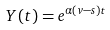Convert formula to latex. <formula><loc_0><loc_0><loc_500><loc_500>Y ( t ) = e ^ { \alpha ( v - s ) t }</formula> 